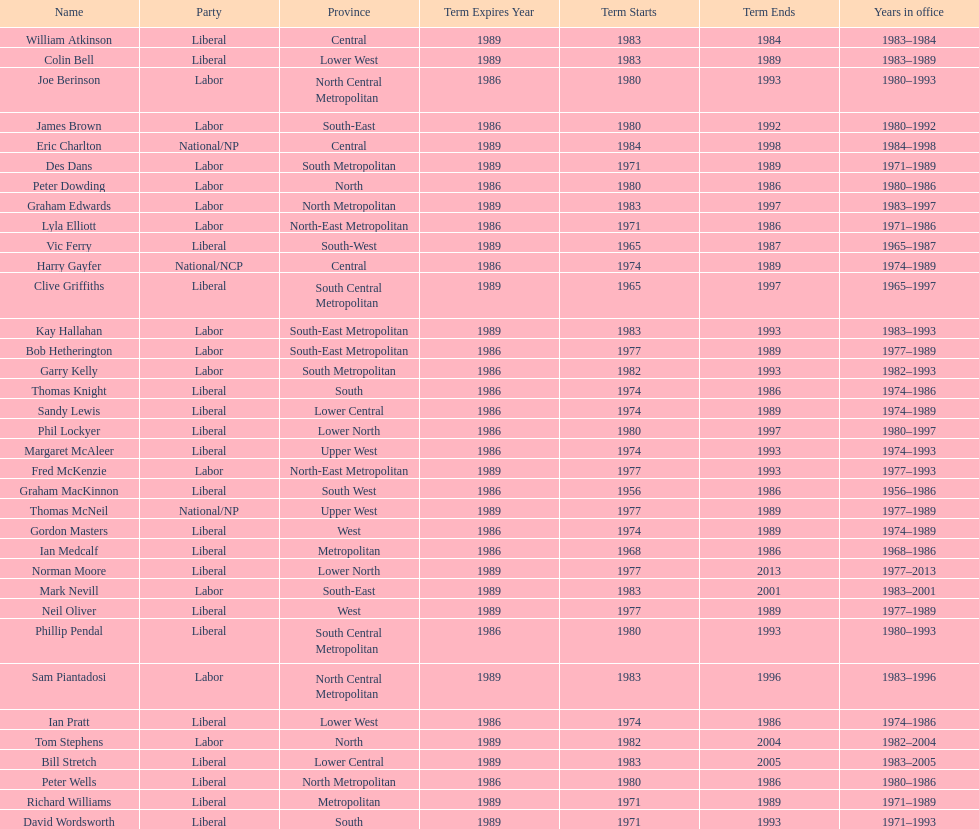What is the total number of members whose term expires in 1989? 9. 